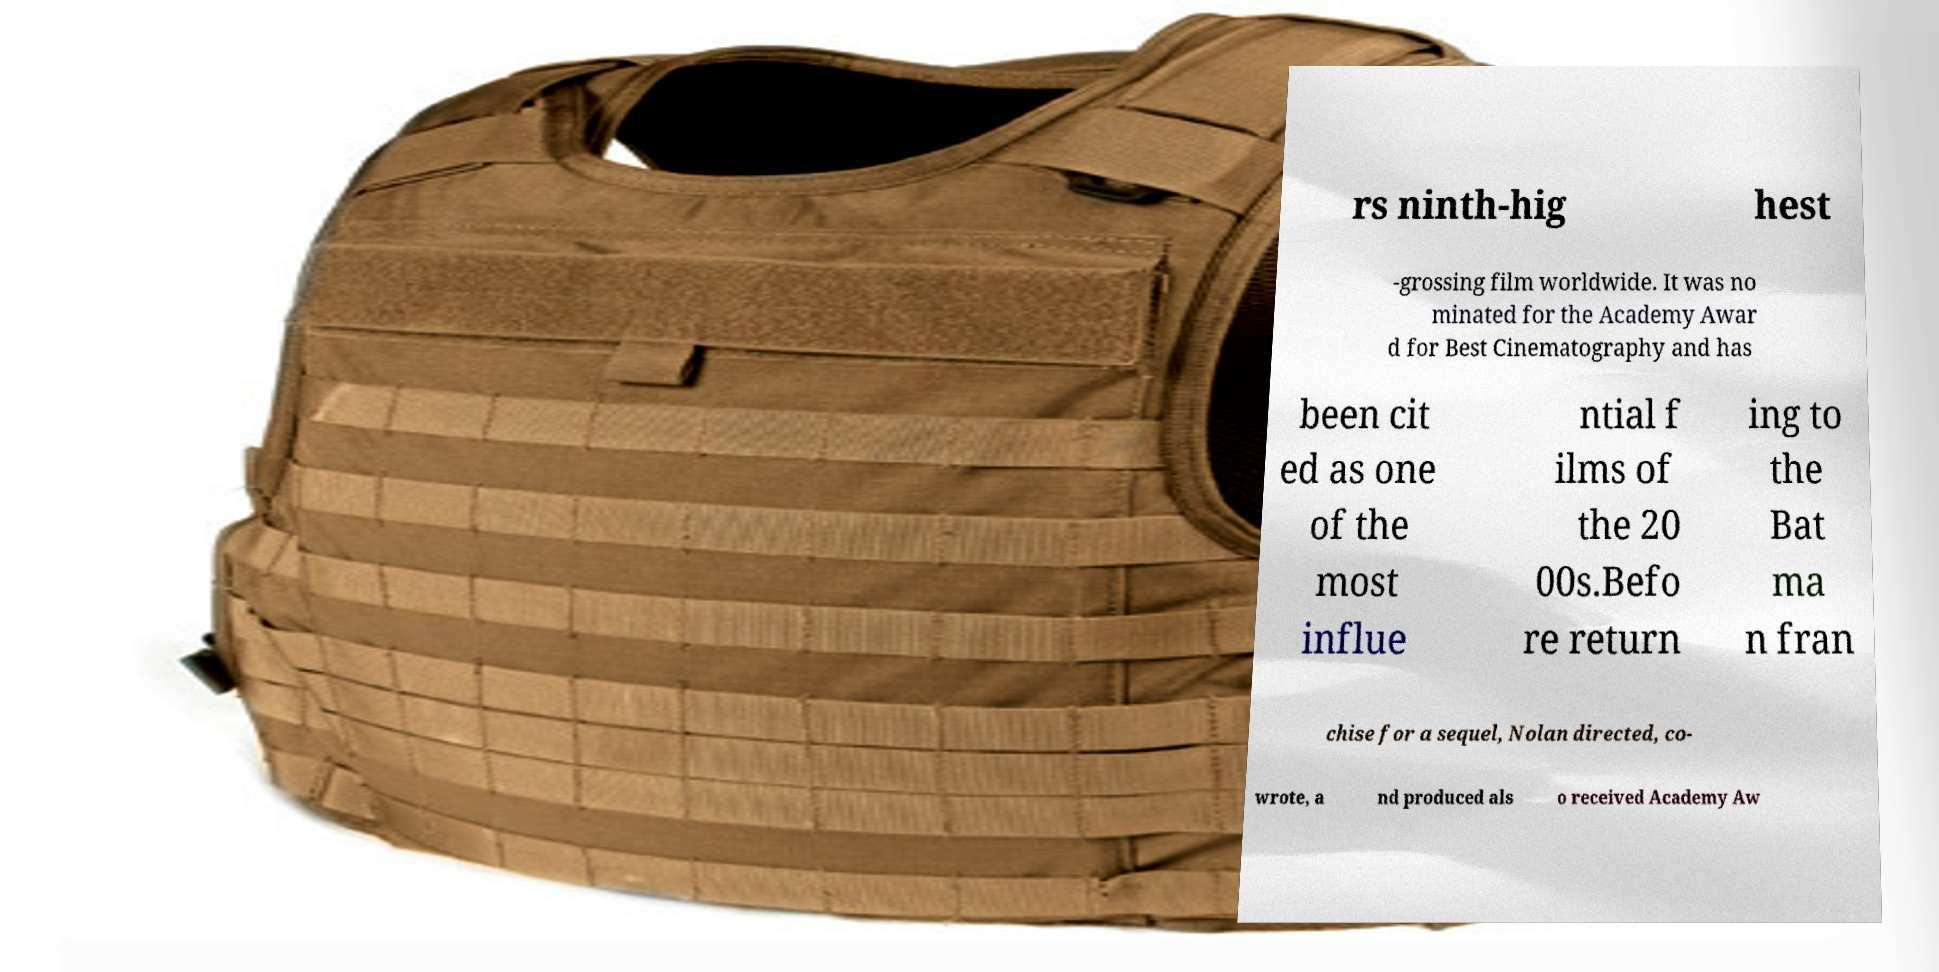Could you extract and type out the text from this image? rs ninth-hig hest -grossing film worldwide. It was no minated for the Academy Awar d for Best Cinematography and has been cit ed as one of the most influe ntial f ilms of the 20 00s.Befo re return ing to the Bat ma n fran chise for a sequel, Nolan directed, co- wrote, a nd produced als o received Academy Aw 